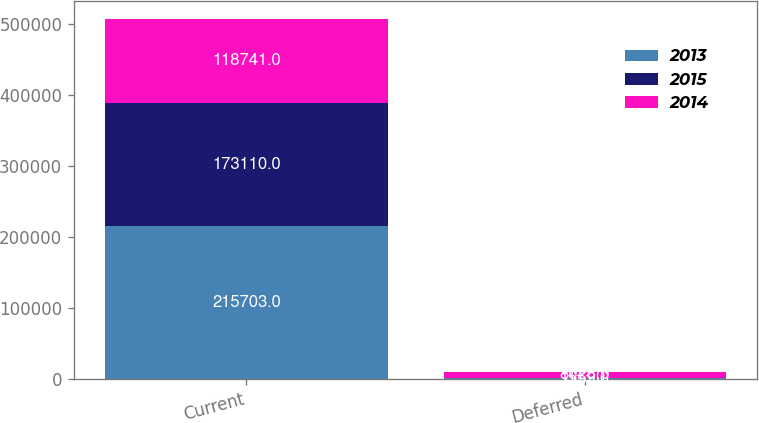Convert chart. <chart><loc_0><loc_0><loc_500><loc_500><stacked_bar_chart><ecel><fcel>Current<fcel>Deferred<nl><fcel>2013<fcel>215703<fcel>1559<nl><fcel>2015<fcel>173110<fcel>333<nl><fcel>2014<fcel>118741<fcel>8023<nl></chart> 